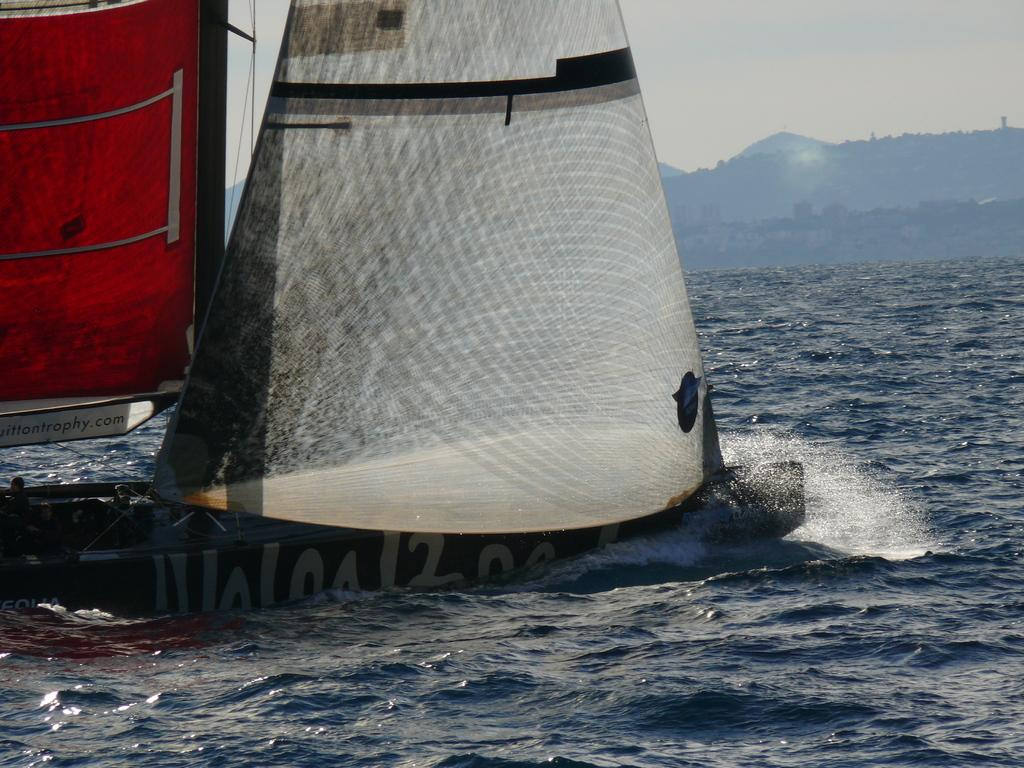What type of vehicles can be seen on the surface of the sea in the image? There are boats on the surface of the sea in the image. What else is visible in the image besides the boats? There is text visible in the image, as well as the sky. What type of prison can be seen in the image? There is no prison present in the image; it features boats on the sea, text, and the sky. How does the text burst out of the image? The text does not burst out of the image; it is stationary and visible within the image. 